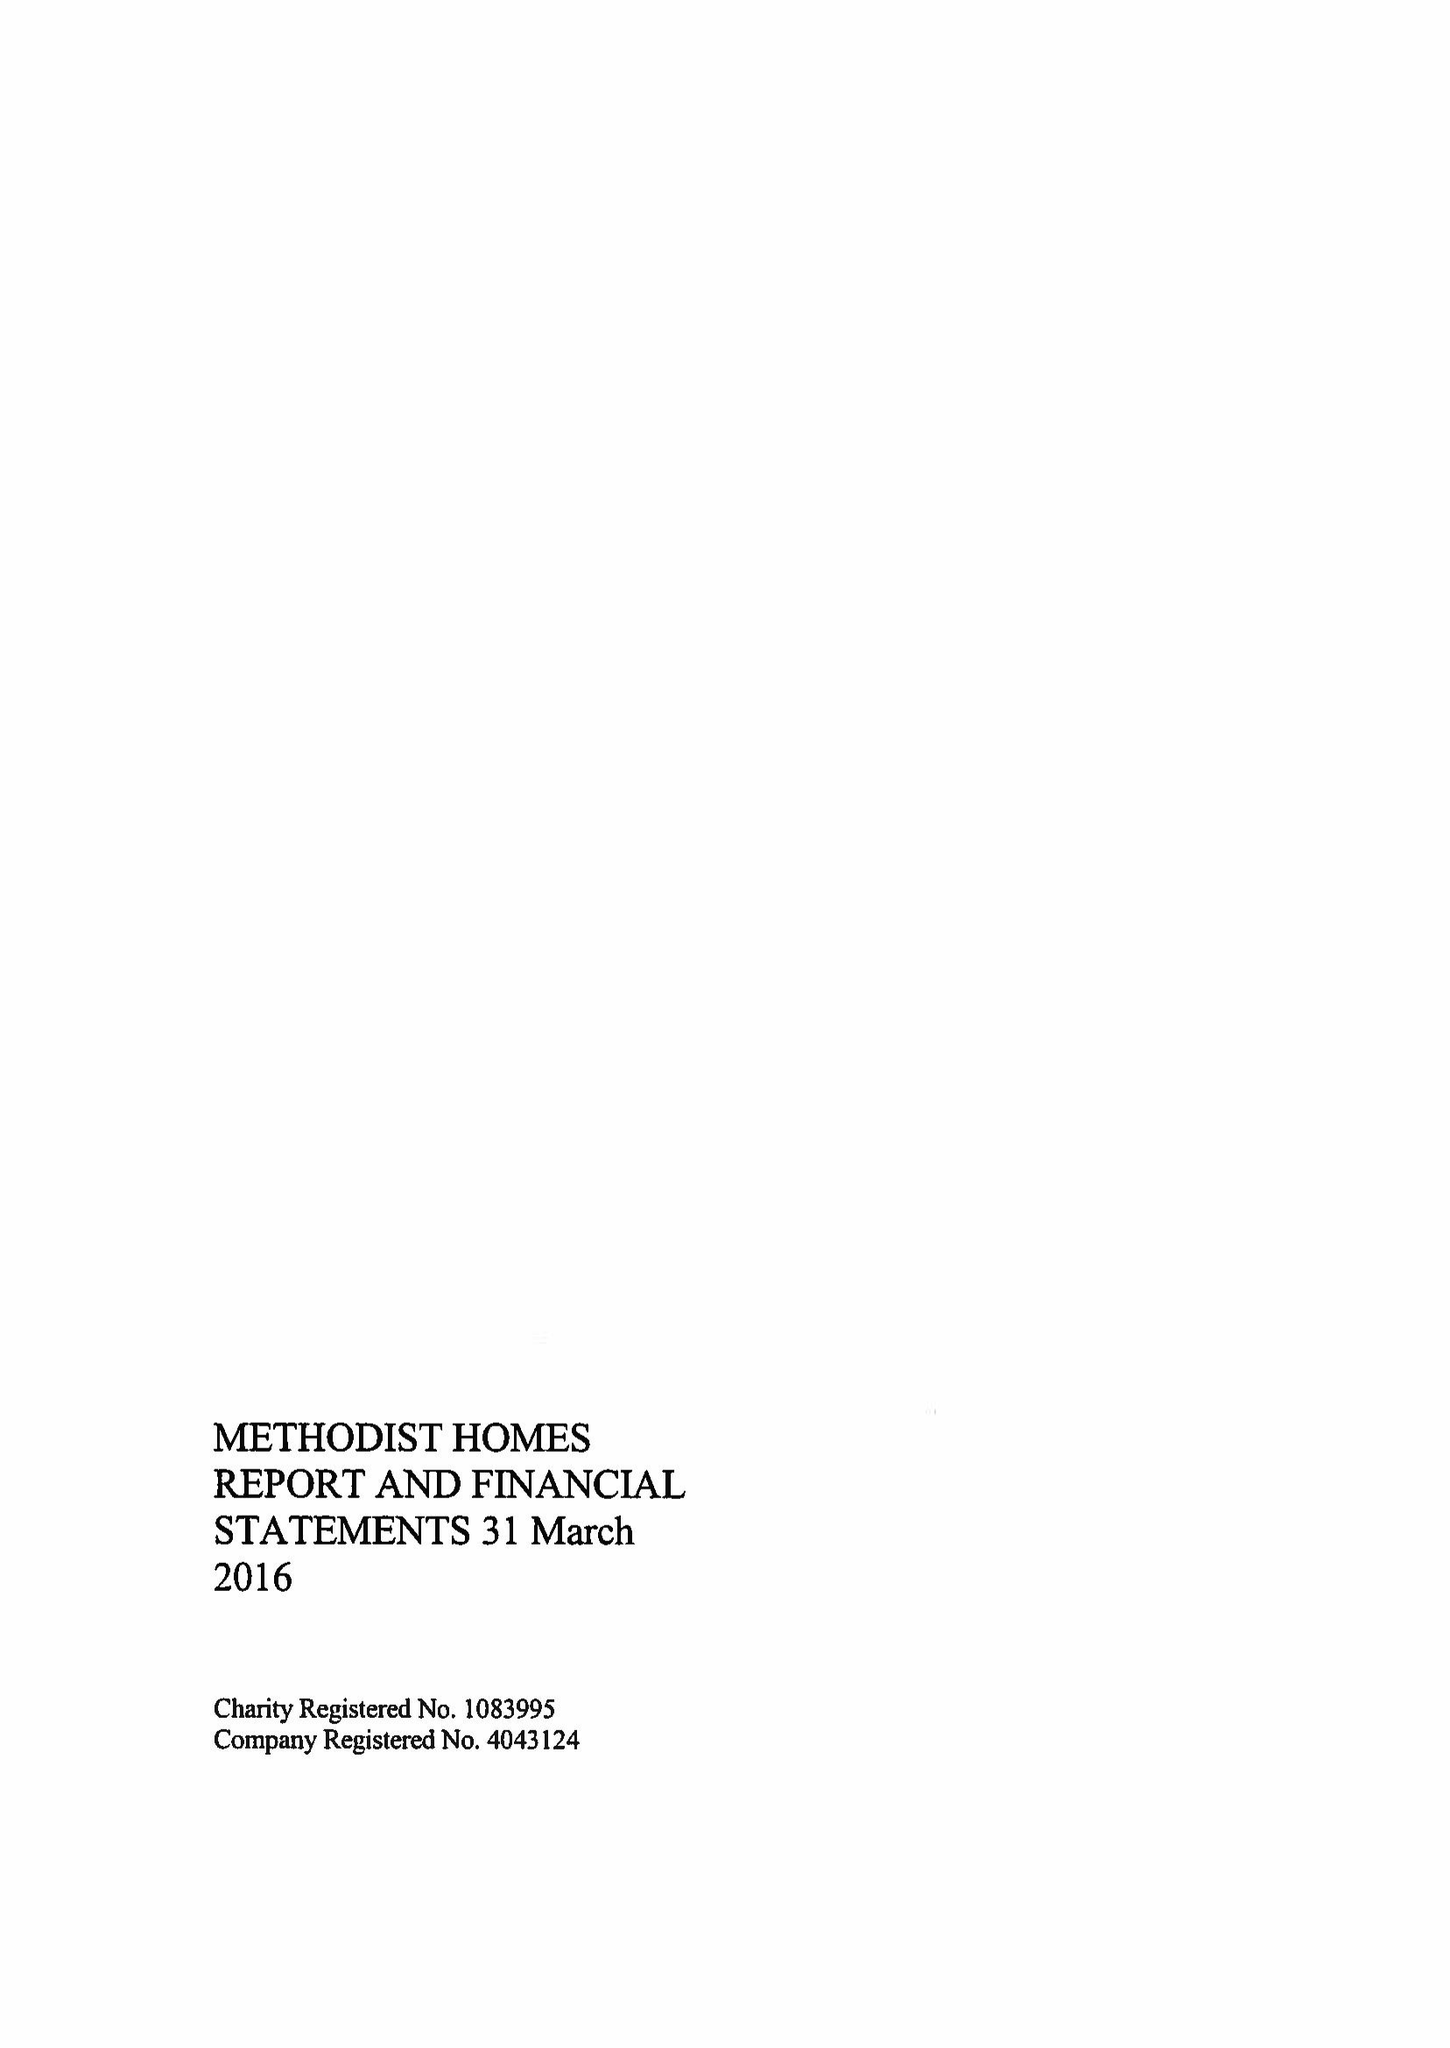What is the value for the address__postcode?
Answer the question using a single word or phrase. DE1 2EQ 